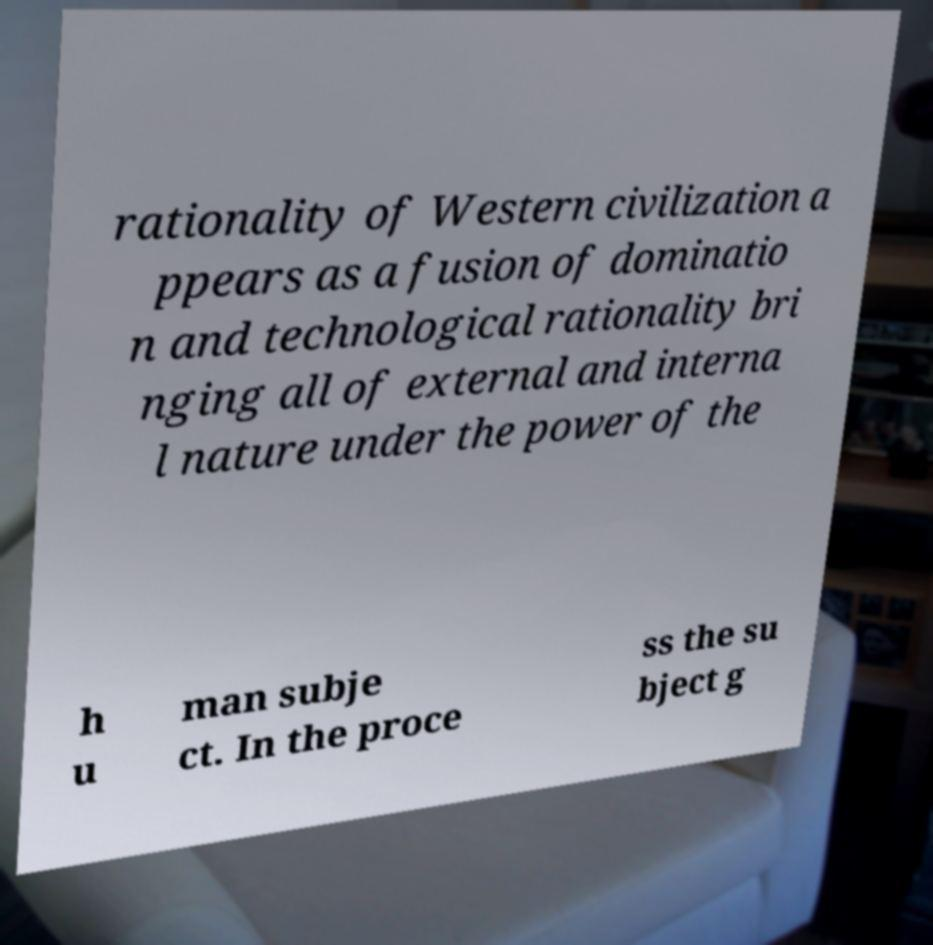Please identify and transcribe the text found in this image. rationality of Western civilization a ppears as a fusion of dominatio n and technological rationality bri nging all of external and interna l nature under the power of the h u man subje ct. In the proce ss the su bject g 